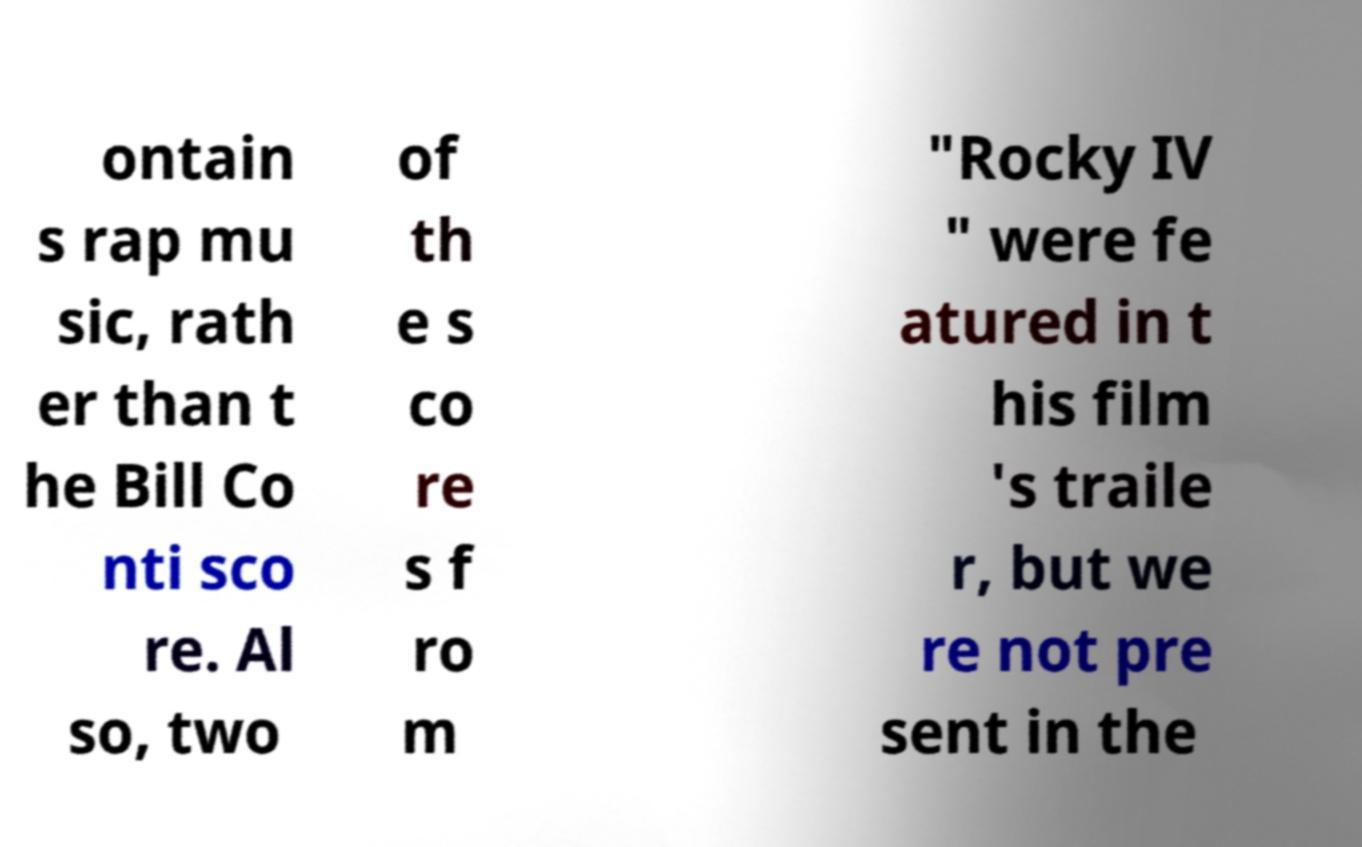Please identify and transcribe the text found in this image. ontain s rap mu sic, rath er than t he Bill Co nti sco re. Al so, two of th e s co re s f ro m "Rocky IV " were fe atured in t his film 's traile r, but we re not pre sent in the 